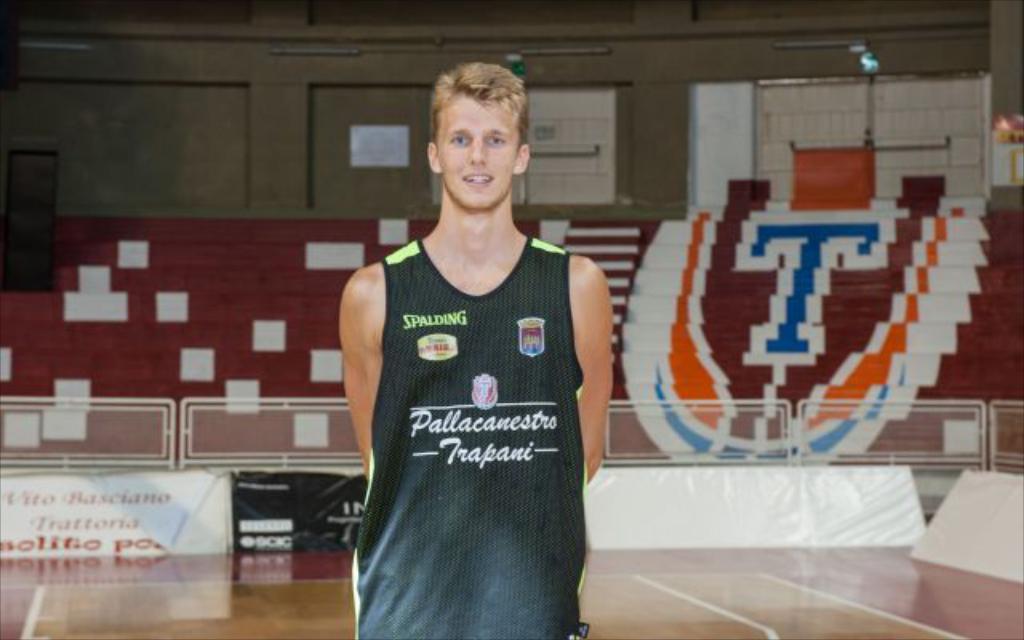What do the green letters on the shirt say?
Offer a terse response. Spalding. 